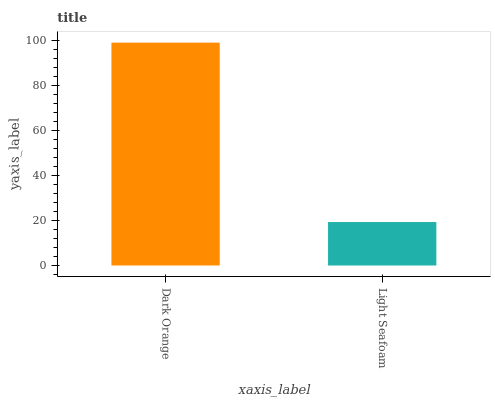Is Light Seafoam the minimum?
Answer yes or no. Yes. Is Dark Orange the maximum?
Answer yes or no. Yes. Is Light Seafoam the maximum?
Answer yes or no. No. Is Dark Orange greater than Light Seafoam?
Answer yes or no. Yes. Is Light Seafoam less than Dark Orange?
Answer yes or no. Yes. Is Light Seafoam greater than Dark Orange?
Answer yes or no. No. Is Dark Orange less than Light Seafoam?
Answer yes or no. No. Is Dark Orange the high median?
Answer yes or no. Yes. Is Light Seafoam the low median?
Answer yes or no. Yes. Is Light Seafoam the high median?
Answer yes or no. No. Is Dark Orange the low median?
Answer yes or no. No. 